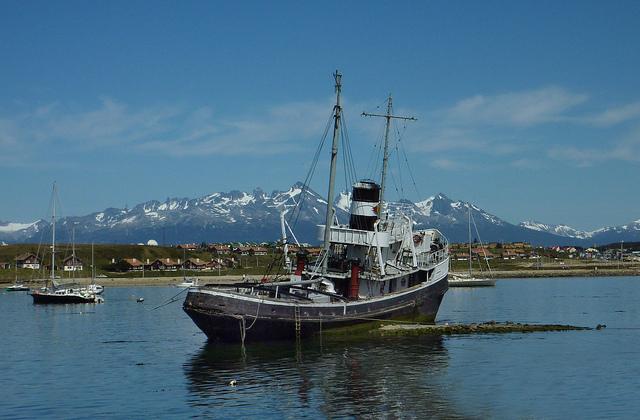Is the boat docked?
Be succinct. No. What is posted at the front of the boat?
Concise answer only. Rope. Where is the bow of the boat?
Write a very short answer. Back. Is the boat in the center of the image a tug boat?
Give a very brief answer. Yes. What are the boats tied to?
Write a very short answer. Dock. Are the mountains snowy?
Keep it brief. Yes. 